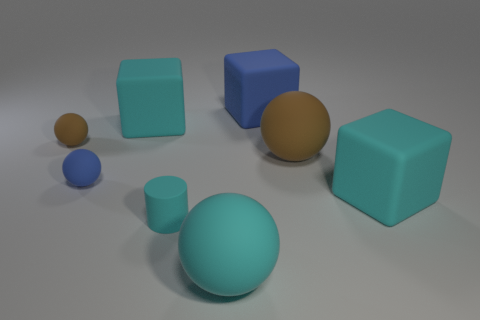Subtract all tiny brown spheres. How many spheres are left? 3 Subtract all cylinders. How many objects are left? 7 Subtract 2 balls. How many balls are left? 2 Subtract all gray cylinders. Subtract all purple spheres. How many cylinders are left? 1 Subtract all purple blocks. How many purple cylinders are left? 0 Subtract all small blue spheres. Subtract all big balls. How many objects are left? 5 Add 6 small blue matte spheres. How many small blue matte spheres are left? 7 Add 2 blue blocks. How many blue blocks exist? 3 Add 1 big cyan rubber objects. How many objects exist? 9 Subtract all blue cubes. How many cubes are left? 2 